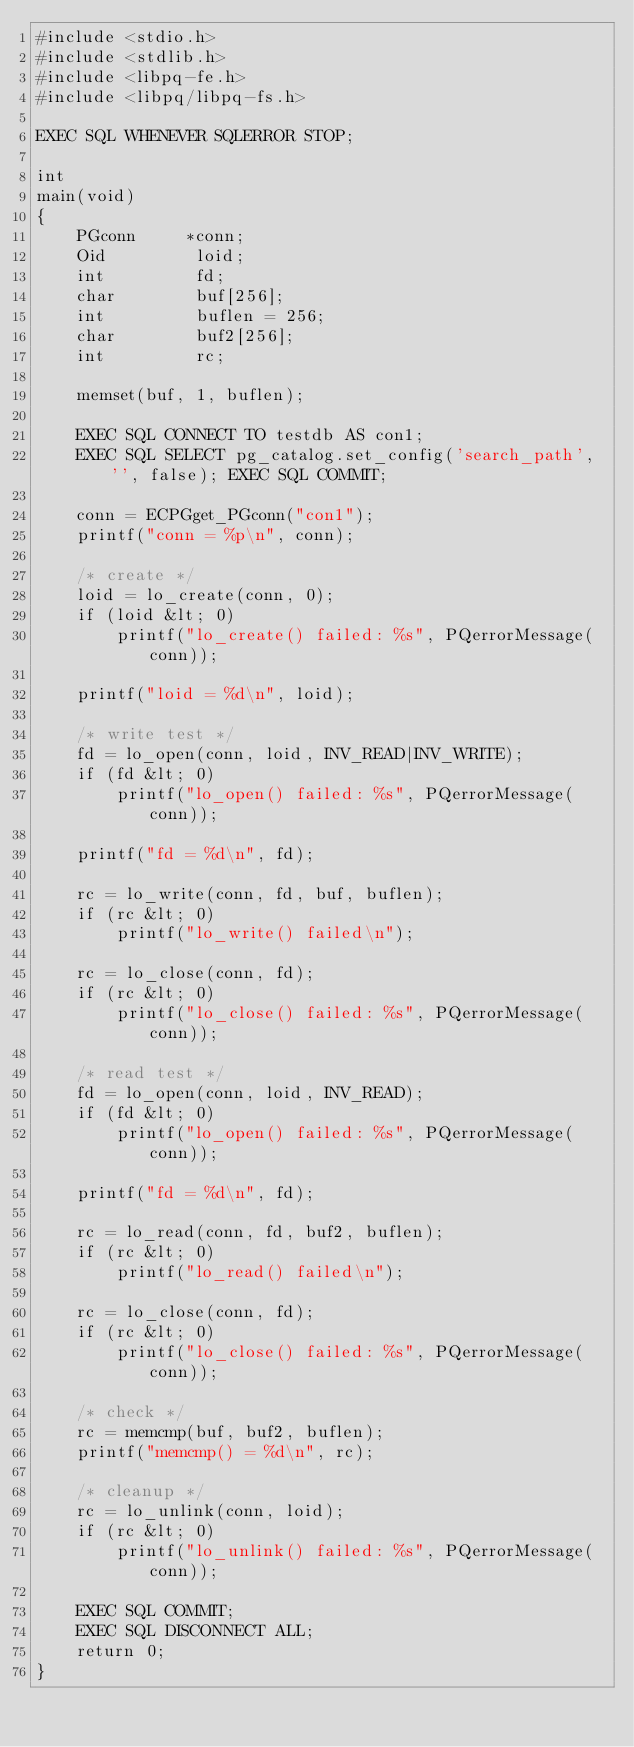<code> <loc_0><loc_0><loc_500><loc_500><_SQL_>#include <stdio.h>
#include <stdlib.h>
#include <libpq-fe.h>
#include <libpq/libpq-fs.h>

EXEC SQL WHENEVER SQLERROR STOP;

int
main(void)
{
    PGconn     *conn;
    Oid         loid;
    int         fd;
    char        buf[256];
    int         buflen = 256;
    char        buf2[256];
    int         rc;

    memset(buf, 1, buflen);

    EXEC SQL CONNECT TO testdb AS con1;
    EXEC SQL SELECT pg_catalog.set_config('search_path', '', false); EXEC SQL COMMIT;

    conn = ECPGget_PGconn("con1");
    printf("conn = %p\n", conn);

    /* create */
    loid = lo_create(conn, 0);
    if (loid &lt; 0)
        printf("lo_create() failed: %s", PQerrorMessage(conn));

    printf("loid = %d\n", loid);

    /* write test */
    fd = lo_open(conn, loid, INV_READ|INV_WRITE);
    if (fd &lt; 0)
        printf("lo_open() failed: %s", PQerrorMessage(conn));

    printf("fd = %d\n", fd);

    rc = lo_write(conn, fd, buf, buflen);
    if (rc &lt; 0)
        printf("lo_write() failed\n");

    rc = lo_close(conn, fd);
    if (rc &lt; 0)
        printf("lo_close() failed: %s", PQerrorMessage(conn));

    /* read test */
    fd = lo_open(conn, loid, INV_READ);
    if (fd &lt; 0)
        printf("lo_open() failed: %s", PQerrorMessage(conn));

    printf("fd = %d\n", fd);

    rc = lo_read(conn, fd, buf2, buflen);
    if (rc &lt; 0)
        printf("lo_read() failed\n");

    rc = lo_close(conn, fd);
    if (rc &lt; 0)
        printf("lo_close() failed: %s", PQerrorMessage(conn));

    /* check */
    rc = memcmp(buf, buf2, buflen);
    printf("memcmp() = %d\n", rc);

    /* cleanup */
    rc = lo_unlink(conn, loid);
    if (rc &lt; 0)
        printf("lo_unlink() failed: %s", PQerrorMessage(conn));

    EXEC SQL COMMIT;
    EXEC SQL DISCONNECT ALL;
    return 0;
}
</code> 